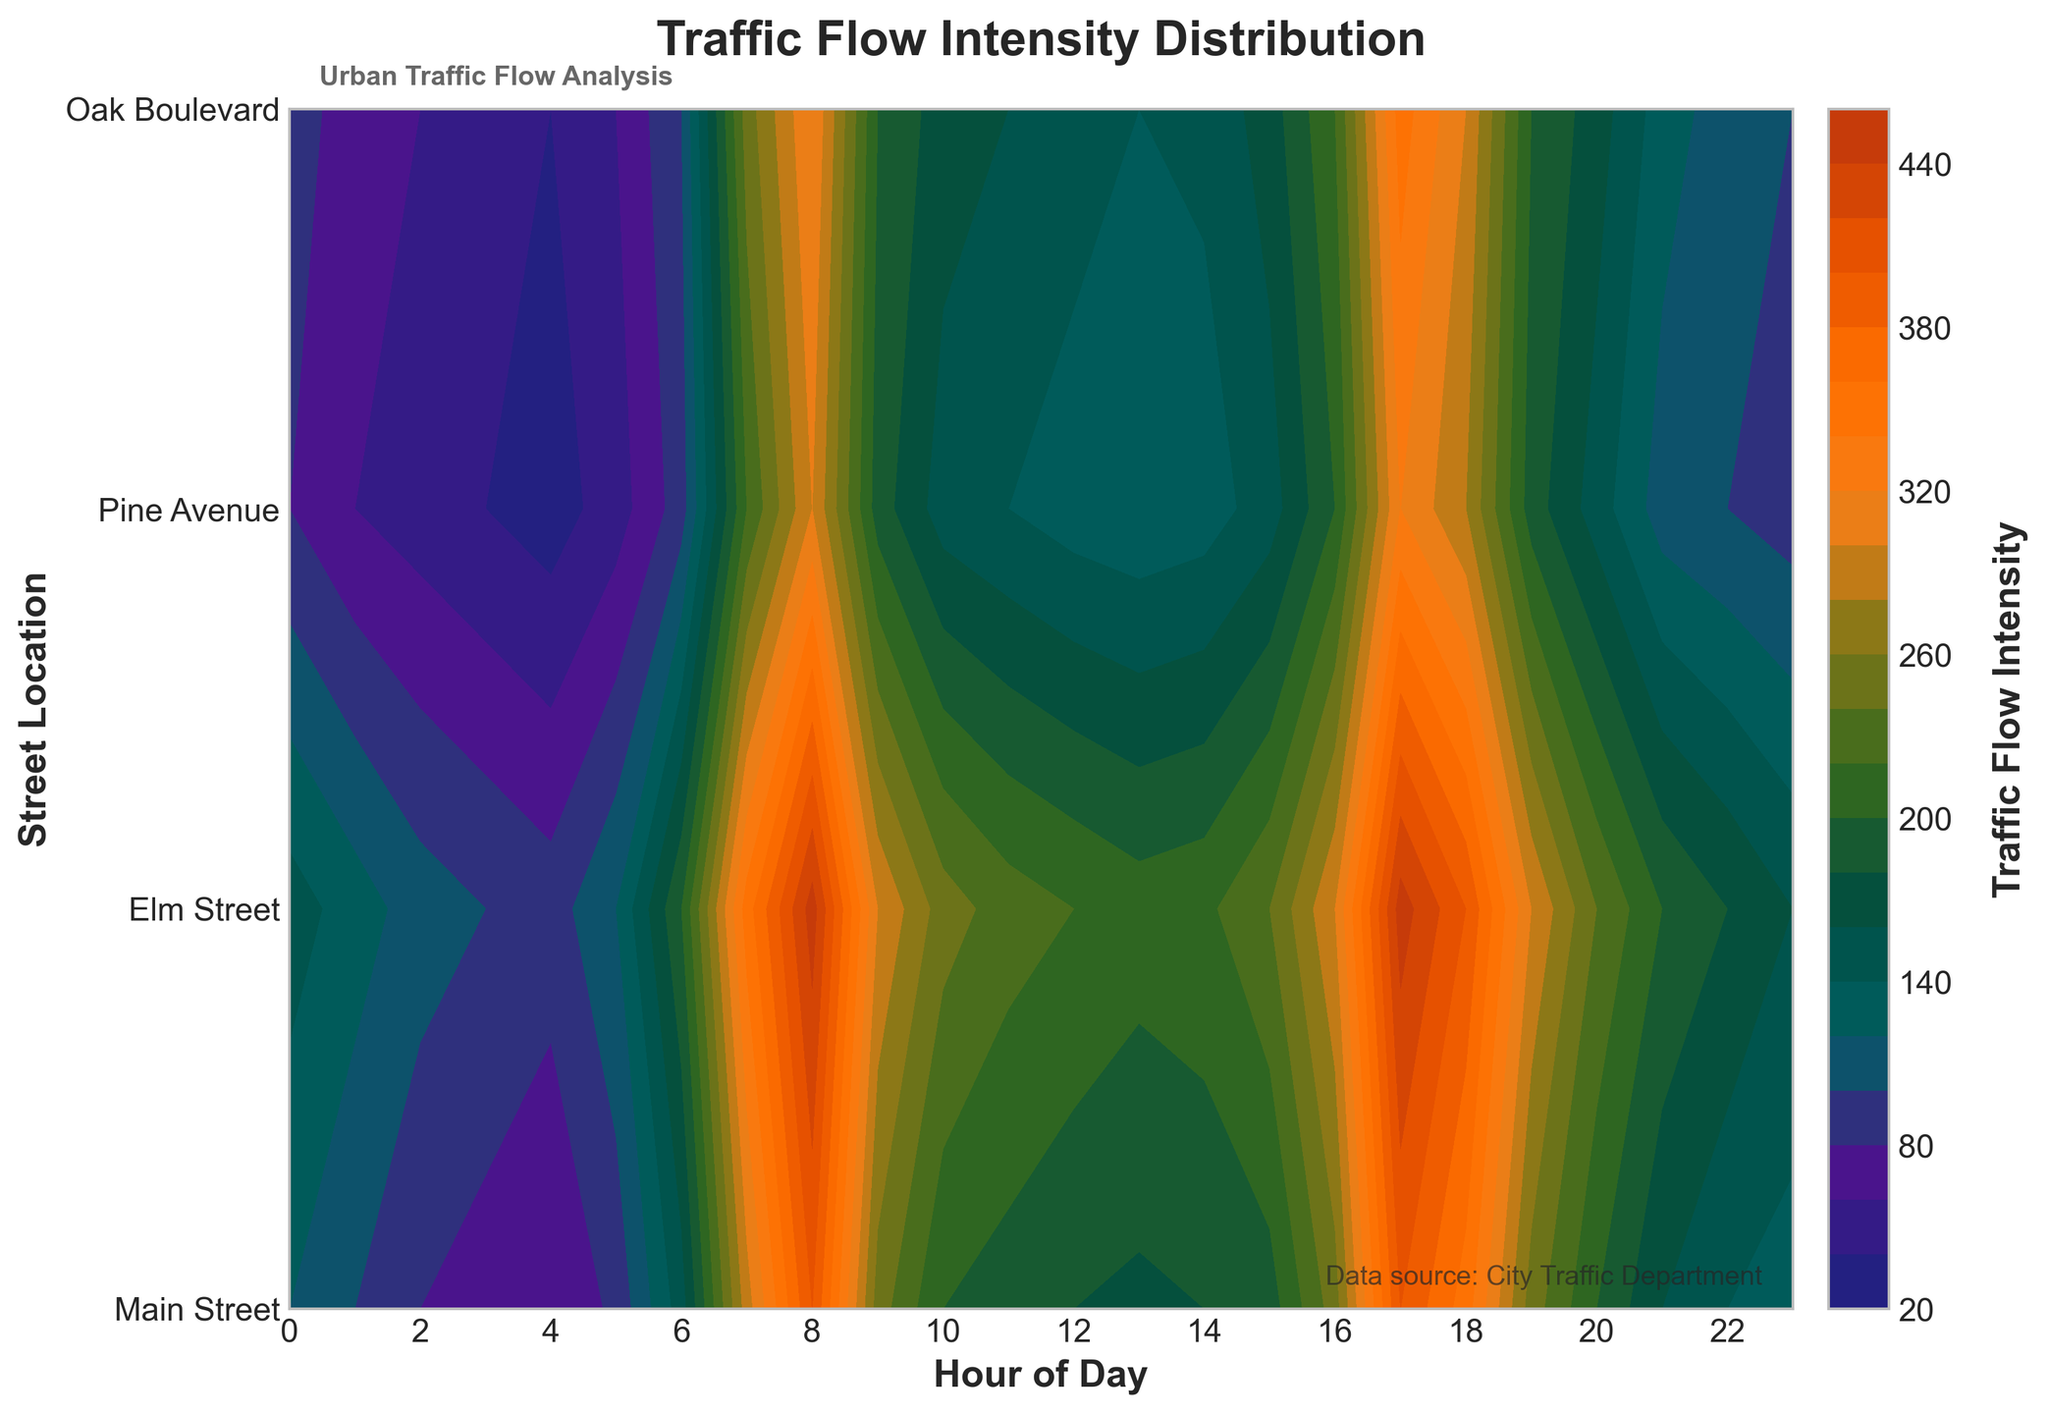How many street locations are depicted in the contour plot? The y-axis depicts the street locations. The y-axis labels indicate the number of street locations shown, which should be counted visually.
Answer: 4 What hours of the day see the highest traffic flow intensity on Elm Street? Look for the brightest color bands on Elm Street across the x-axis. These correspond to the highest traffic flow intensity periods. Visually identify these hours.
Answer: 8 AM and 5 PM Based on the contour plot, during which hours does traffic flow intensity on Main Street start to rise significantly? Observe the color change on the Main Street row on the y-axis. Identify the hour where the color gradient noticeably shifts to warmer tones, indicating an increase in traffic flow intensity.
Answer: Around 6 AM Which street location experiences the highest traffic flow intensity and at what time? Identify the location with the most intense color (warmest tones) and note the corresponding hour on the x-axis where this peak occurs.
Answer: Main Street at 8 AM How does traffic flow intensity on Oak Boulevard around 9 AM compare to that on Pine Avenue at the same time? Compare the color representation for 9 AM on both Oak Boulevard and Pine Avenue. Note which color appears more intense.
Answer: Slightly higher on Pine Avenue Which time period shows the steepest drop in traffic flow intensity across all locations? Look for the swiftest color change from warm to cool tones across multiple columns at specific hours. This indicates the steepest decline in flow intensity.
Answer: After 8 AM What is the general trend of traffic flow intensity at Main Street from midnight to 4 AM? Examine the color gradient along the timeline from midnight to 4 AM on Main Street. Identify whether it remains stable, increases, or decreases.
Answer: Decreasing What's the average traffic flow intensity during 2 PM across all street locations? Find the color bands for 2 PM on all specified street locations, average the traffic flow values represented by those color bands.
Answer: Around 170 Between 4 PM and 6 PM, which street location experiences the least variance in traffic flow intensity? Compare the color gradient changes between 4 PM and 6 PM across all street locations. The location with the least change shows the least variance.
Answer: Oak Boulevard During which time period does Pine Avenue experience a consistent traffic flow intensity without significant peaks or drops? Look for a color band representing a uniform tone on Pine Avenue along the x-axis, indicating a stable traffic flow intensity without fluctuations.
Answer: 10 AM to 4 PM 